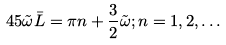Convert formula to latex. <formula><loc_0><loc_0><loc_500><loc_500>4 5 \tilde { \omega } \bar { L } = \pi n + \frac { 3 } { 2 } \tilde { \omega } ; n = 1 , 2 , \dots</formula> 